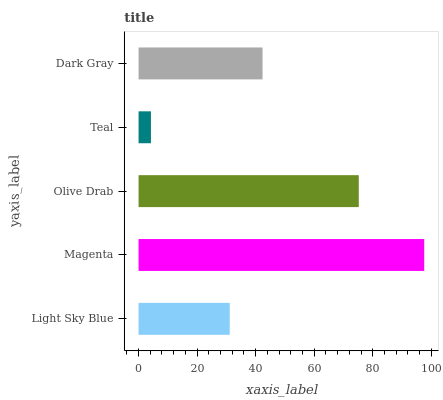Is Teal the minimum?
Answer yes or no. Yes. Is Magenta the maximum?
Answer yes or no. Yes. Is Olive Drab the minimum?
Answer yes or no. No. Is Olive Drab the maximum?
Answer yes or no. No. Is Magenta greater than Olive Drab?
Answer yes or no. Yes. Is Olive Drab less than Magenta?
Answer yes or no. Yes. Is Olive Drab greater than Magenta?
Answer yes or no. No. Is Magenta less than Olive Drab?
Answer yes or no. No. Is Dark Gray the high median?
Answer yes or no. Yes. Is Dark Gray the low median?
Answer yes or no. Yes. Is Light Sky Blue the high median?
Answer yes or no. No. Is Light Sky Blue the low median?
Answer yes or no. No. 